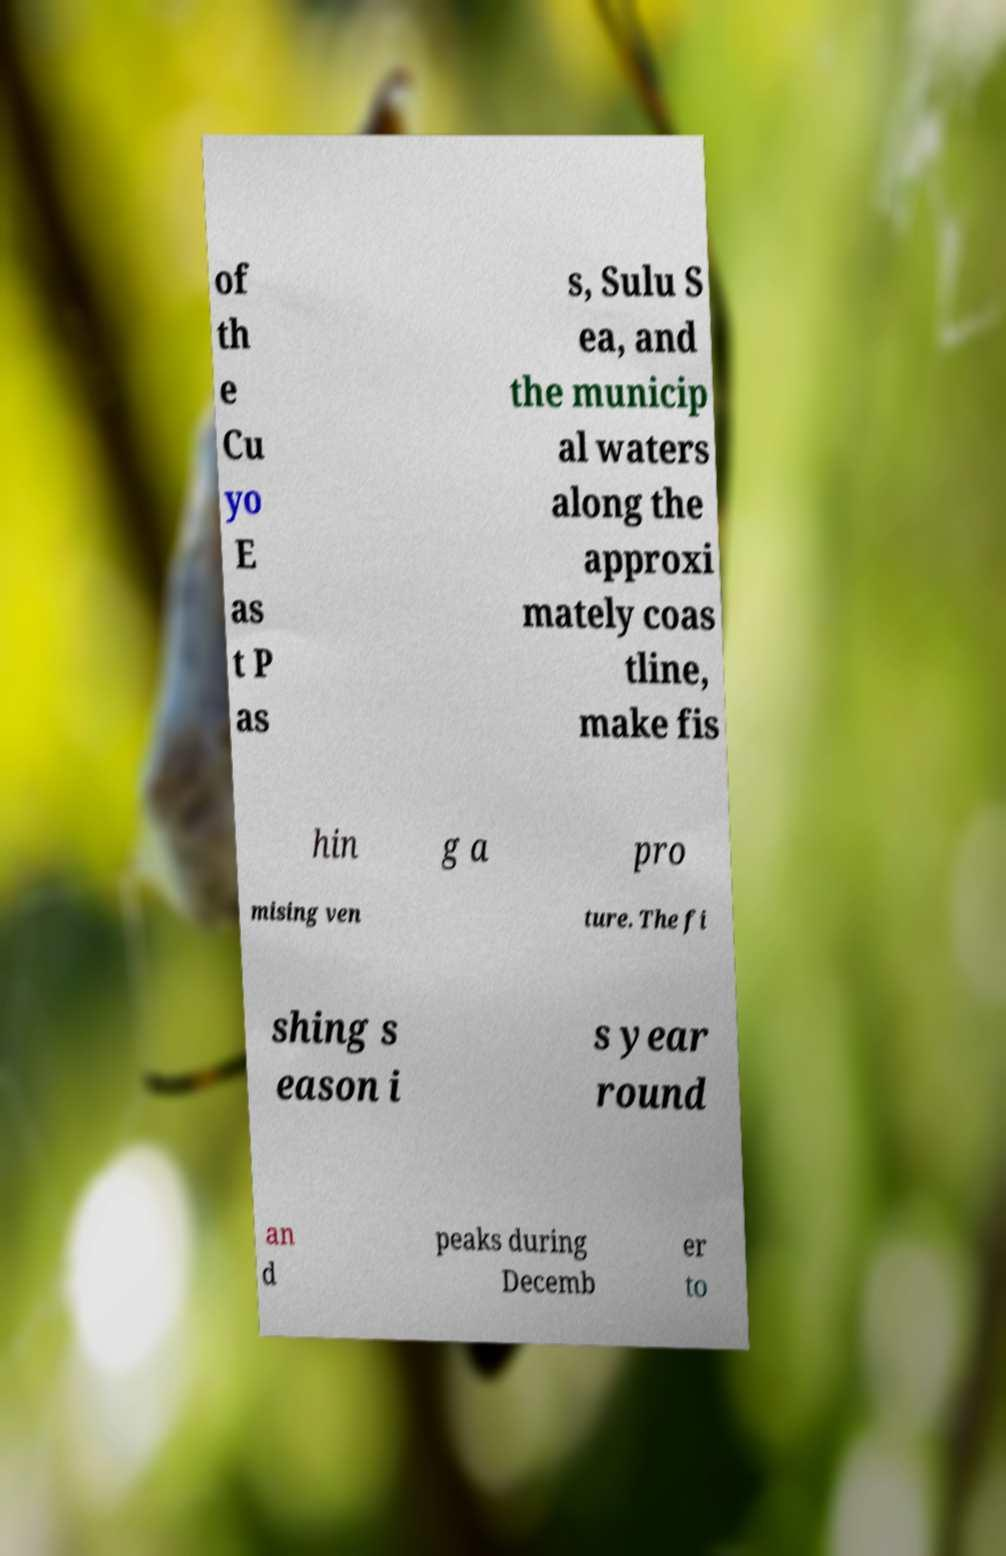Could you assist in decoding the text presented in this image and type it out clearly? of th e Cu yo E as t P as s, Sulu S ea, and the municip al waters along the approxi mately coas tline, make fis hin g a pro mising ven ture. The fi shing s eason i s year round an d peaks during Decemb er to 